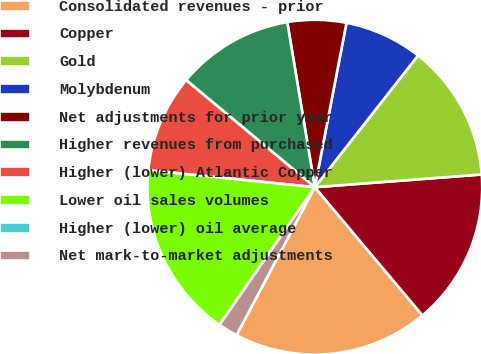<chart> <loc_0><loc_0><loc_500><loc_500><pie_chart><fcel>Consolidated revenues - prior<fcel>Copper<fcel>Gold<fcel>Molybdenum<fcel>Net adjustments for prior year<fcel>Higher revenues from purchased<fcel>Higher (lower) Atlantic Copper<fcel>Lower oil sales volumes<fcel>Higher (lower) oil average<fcel>Net mark-to-market adjustments<nl><fcel>18.86%<fcel>15.09%<fcel>13.21%<fcel>7.55%<fcel>5.66%<fcel>11.32%<fcel>9.43%<fcel>16.98%<fcel>0.0%<fcel>1.89%<nl></chart> 